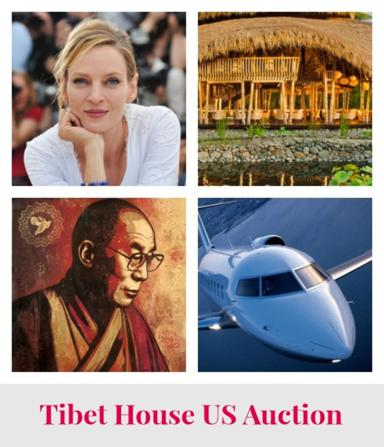What is the main subject of the image? The main subject of the image is the Tibet House US Auction, which is represented through a collage illustrating various themes like cultural figures, travel, and personal portraits, symbolizing the broad interests and global reach of the auction. 